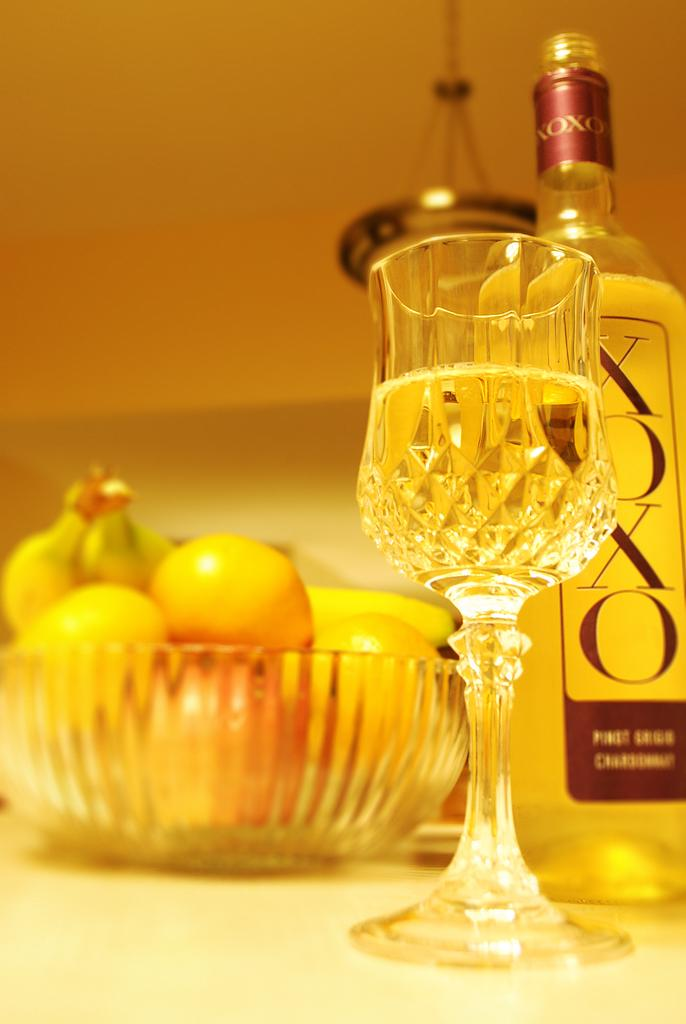What is in the bowl that is visible in the image? There is a bowl with fruits in the image. What other items can be seen in the image besides the bowl of fruits? There is a glass and a bottle in the image. Where are the glass and the bottle located in the image? The glass and the bottle are on the surface in the image. What can be seen in the background of the image? There is an object visible in the background of the image, and there is also a wall in the background. What type of hearing aid is the fruit using in the image? There is no hearing aid present in the image, as the subject is a bowl of fruits. 